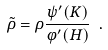Convert formula to latex. <formula><loc_0><loc_0><loc_500><loc_500>\tilde { \rho } = \rho \frac { \psi ^ { \prime } ( K ) } { \varphi ^ { \prime } ( H ) } \ .</formula> 